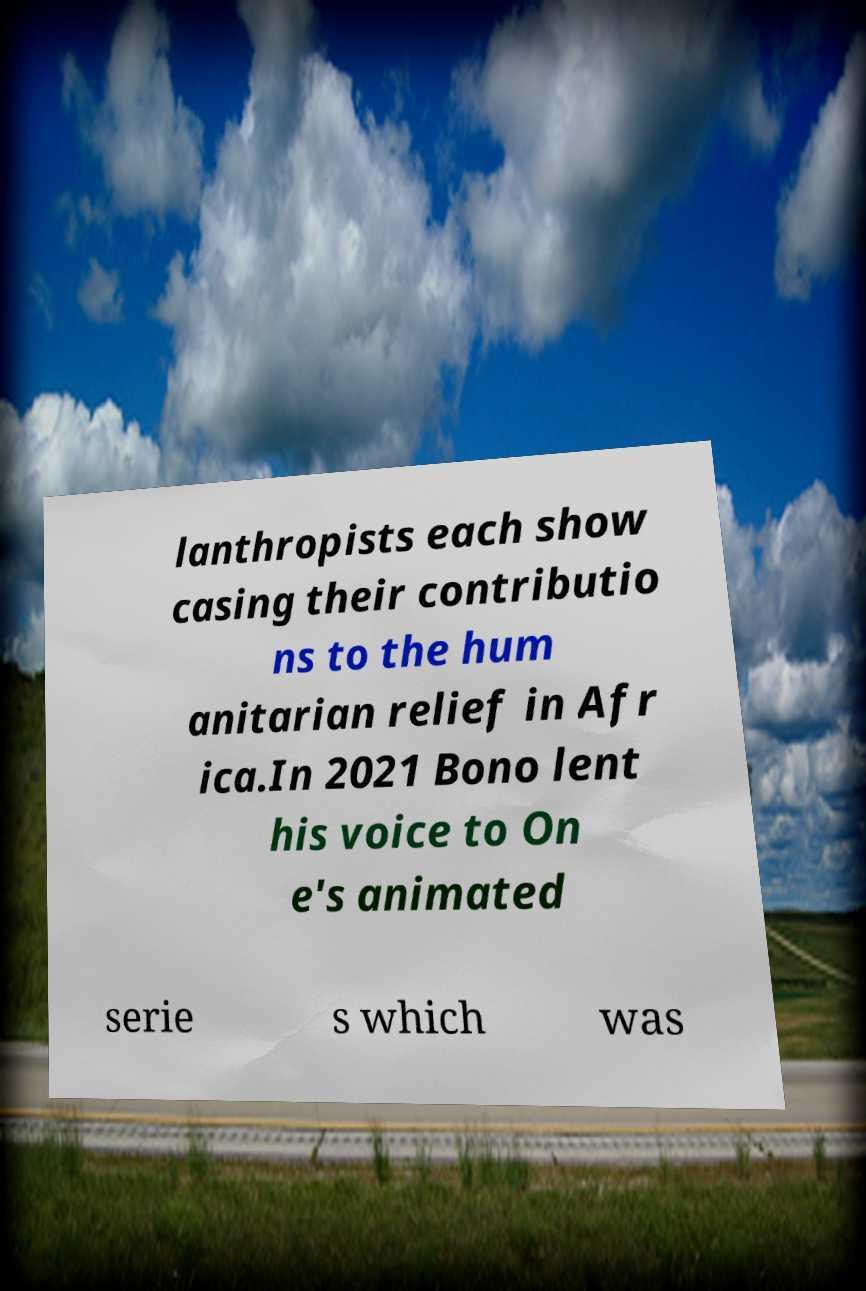There's text embedded in this image that I need extracted. Can you transcribe it verbatim? lanthropists each show casing their contributio ns to the hum anitarian relief in Afr ica.In 2021 Bono lent his voice to On e's animated serie s which was 